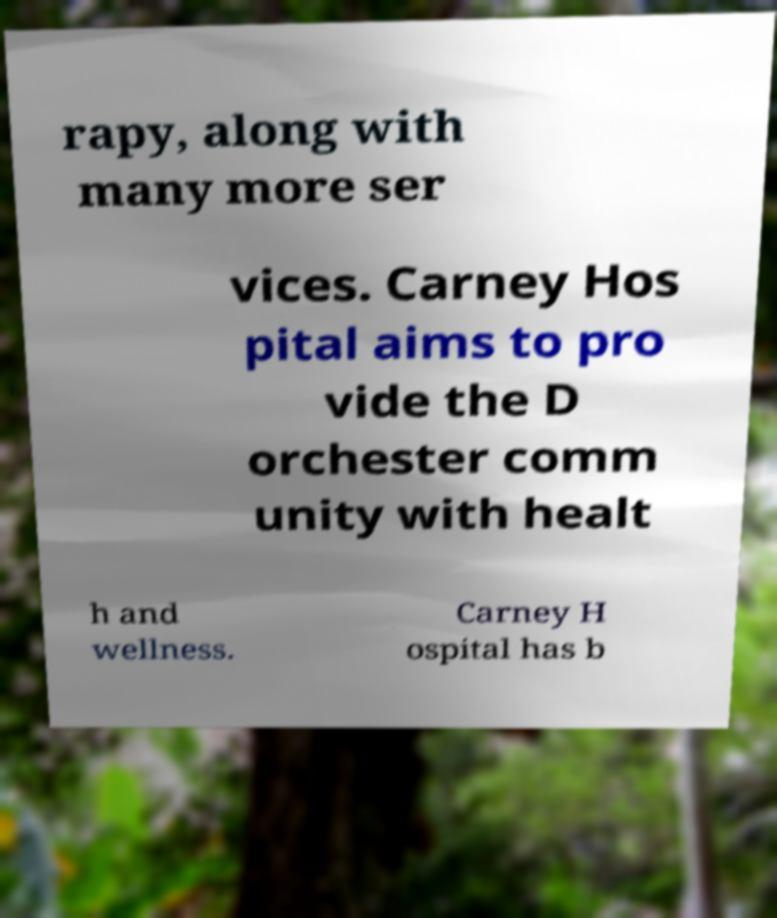For documentation purposes, I need the text within this image transcribed. Could you provide that? rapy, along with many more ser vices. Carney Hos pital aims to pro vide the D orchester comm unity with healt h and wellness. Carney H ospital has b 